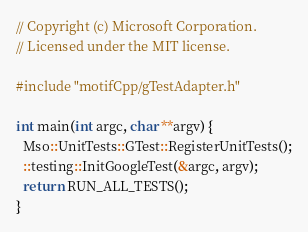<code> <loc_0><loc_0><loc_500><loc_500><_C++_>// Copyright (c) Microsoft Corporation.
// Licensed under the MIT license.

#include "motifCpp/gTestAdapter.h"

int main(int argc, char **argv) {
  Mso::UnitTests::GTest::RegisterUnitTests();
  ::testing::InitGoogleTest(&argc, argv);
  return RUN_ALL_TESTS();
}
</code> 